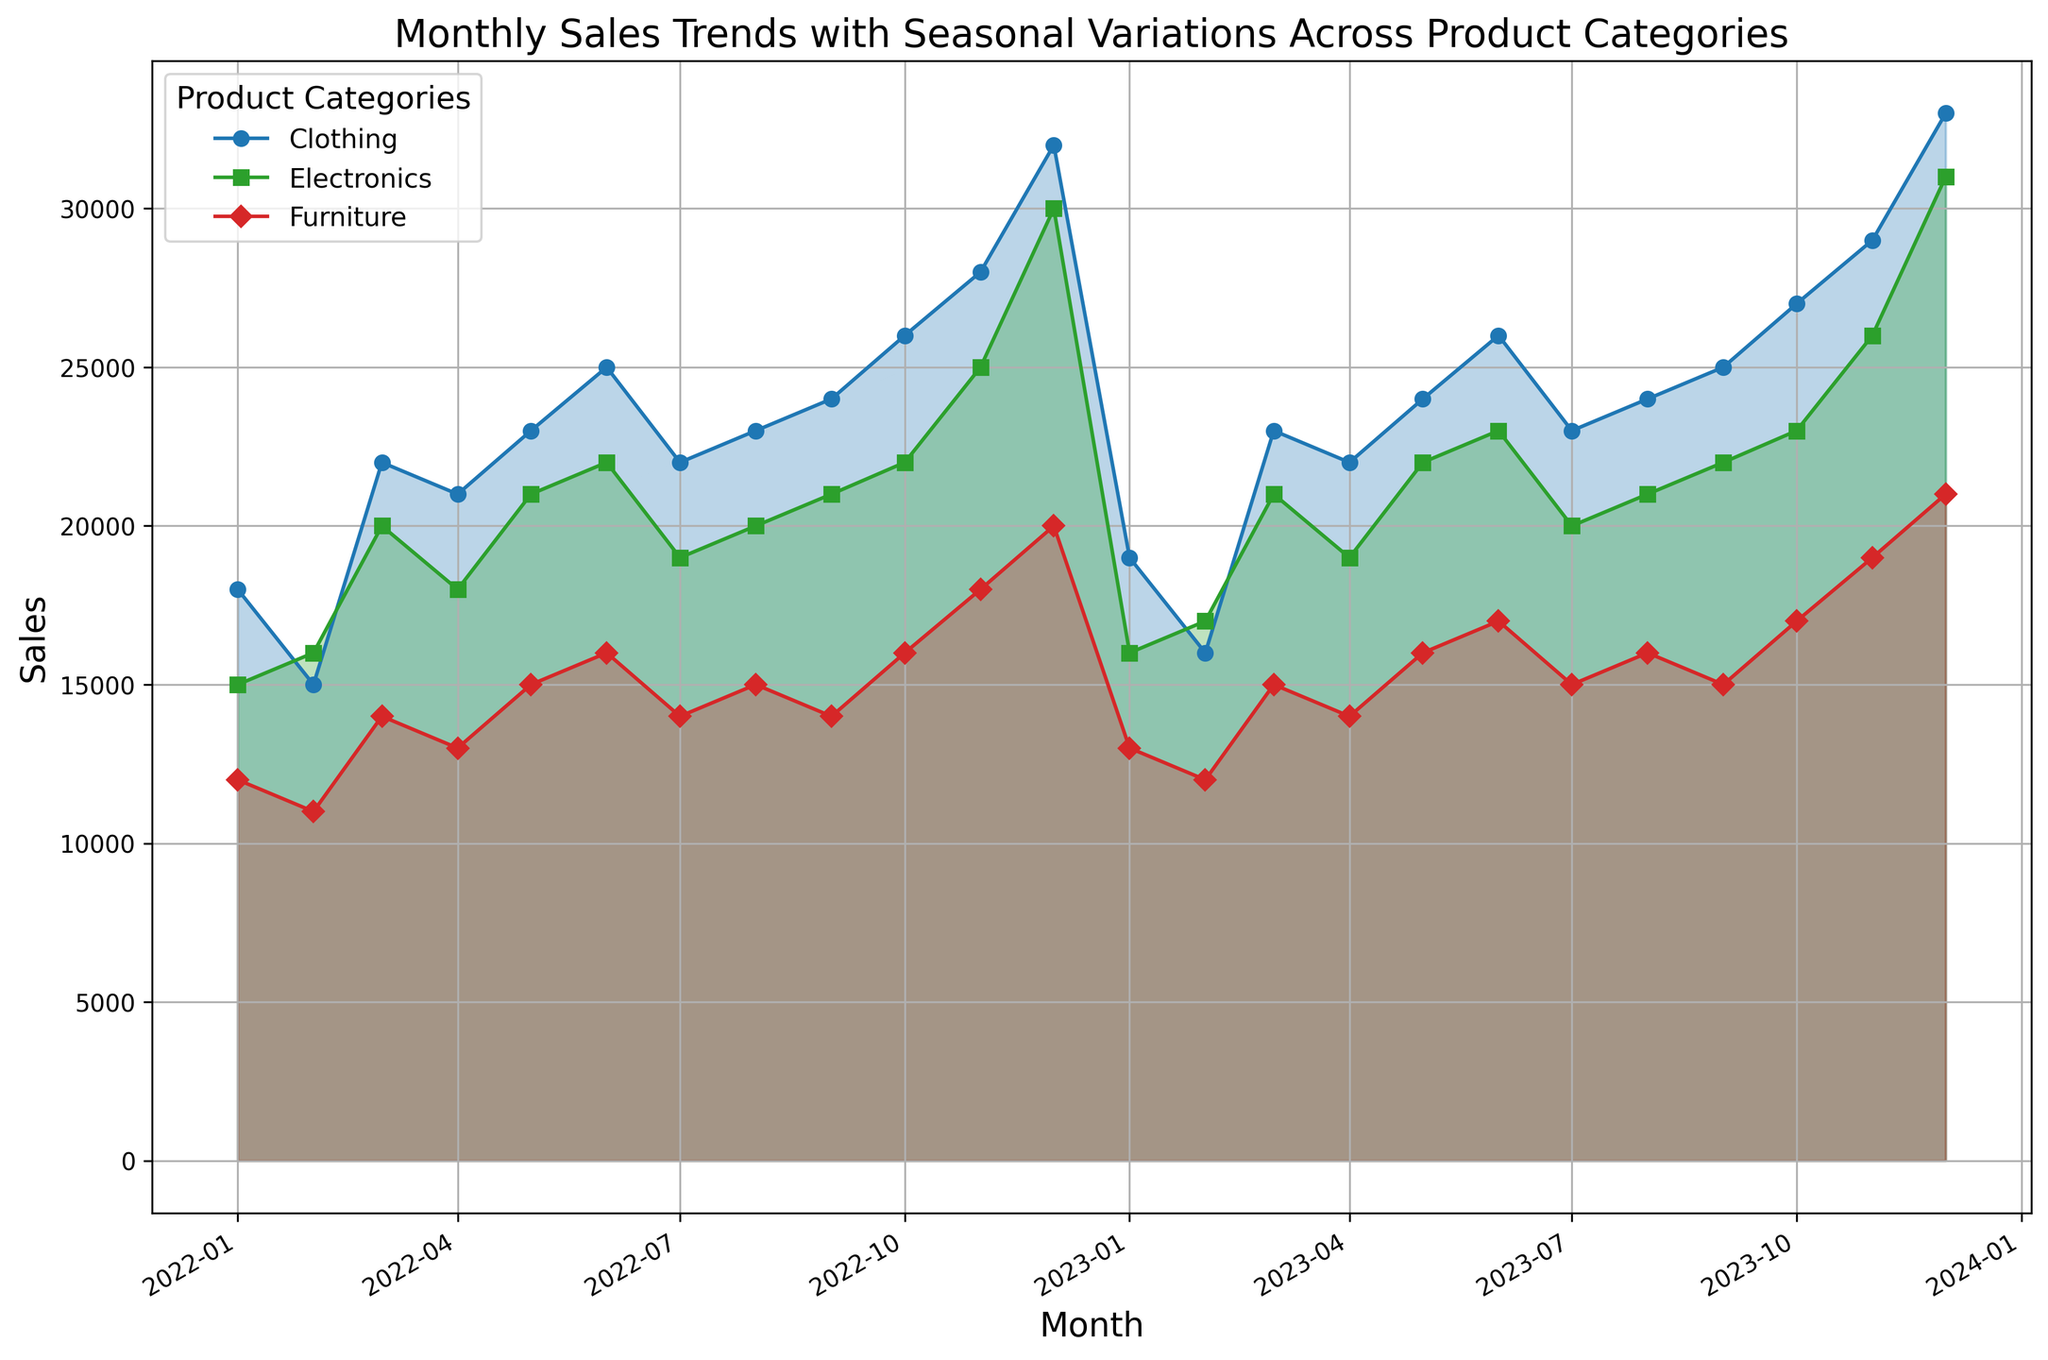What is the month with the highest sales for Electronics? The month with the highest sales for Electronics is the one with the highest peak in the blue line. By checking the highest point in the blue line, which is around December 2023.
Answer: December 2023 Which category shows the highest overall sales throughout the year? To find this, compare the overall height and peaks of the lines. The red line consistently reaches higher levels compared to the green and blue lines, especially during the end of the years.
Answer: Clothing In which month did Furniture experience its highest sales in 2023? Look for the green line peaks for Furniture in the data points in 2023. The highest peak for Furniture in 2023 is in December.
Answer: December 2023 During which months did Electronics have a visible decrease in sales? Follow the blue line to identify segments where the values drop from one month to the next. The blue line has visible decreases from June 2022 to July 2022 and from December 2022 to January 2023.
Answer: July 2022, January 2023 What are the two consecutive months where Clothing sales saw the highest increase in 2022? Look for the largest slope in the red line. The largest increase in the red line occurs between November 2022 and December 2022.
Answer: November 2022 to December 2022 How do the sales of Furniture in October 2022 compare to its sales in October 2023? Check the values of the green line around October 2022 and October 2023. The sales for Furniture in October 2022 were around 16,000 and for October 2023 are about the same, 17,000.
Answer: Similar, slight increase in 2023 Which category had the most consistent sales throughout the period shown? Look for the line that appears the least volatile in terms of peaks and troughs. The green line for Furniture appears the most stable relative to the other lines.
Answer: Furniture Between which two months in 2023 did Electronics see the largest relative drop in sales? Identify the blue line's largest vertical drop within the months of 2023. The biggest drop for Electronics in 2023 was between October and November.
Answer: October 2023 to November 2023 What is the sales difference for Clothing between December 2022 and January 2023? Find the values of the red line for these two months and compute the difference. December 2022 is 32,000 and January 2023 is 19,000. The difference is 32,000 - 19,000.
Answer: 13,000 